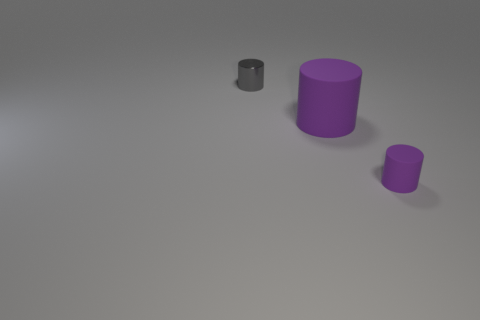What number of things are the same color as the large matte cylinder?
Your response must be concise. 1. What is the tiny cylinder that is in front of the shiny cylinder made of?
Provide a succinct answer. Rubber. How many objects are either purple matte cylinders that are in front of the large matte cylinder or small matte balls?
Give a very brief answer. 1. Is the shape of the purple object to the right of the big purple cylinder the same as  the big thing?
Offer a very short reply. Yes. There is a gray cylinder; are there any tiny cylinders behind it?
Your answer should be very brief. No. What number of large objects are cylinders or purple cylinders?
Keep it short and to the point. 1. Do the gray cylinder and the big thing have the same material?
Your answer should be very brief. No. The other cylinder that is the same color as the big rubber cylinder is what size?
Make the answer very short. Small. Is there a rubber thing of the same color as the large rubber cylinder?
Give a very brief answer. Yes. What is the size of the cylinder that is made of the same material as the small purple object?
Offer a very short reply. Large. 